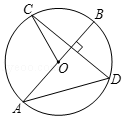Provide a description of what is shown in the illustration. The diagram shows a circle labeled as circle O. The circle has a diameter AB, which is a line segment passing through its center. Inside the circle, there is a chord CD that intersects the diameter at point D and is perpendicular to it. 